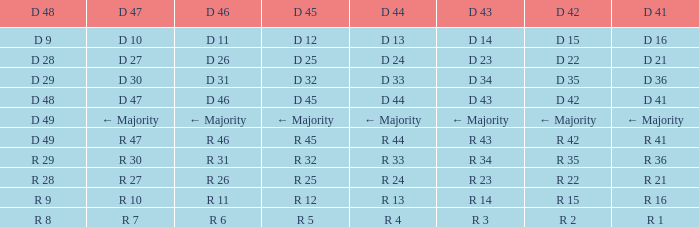Name the D 48 when it has a D 44 of d 33 D 29. 